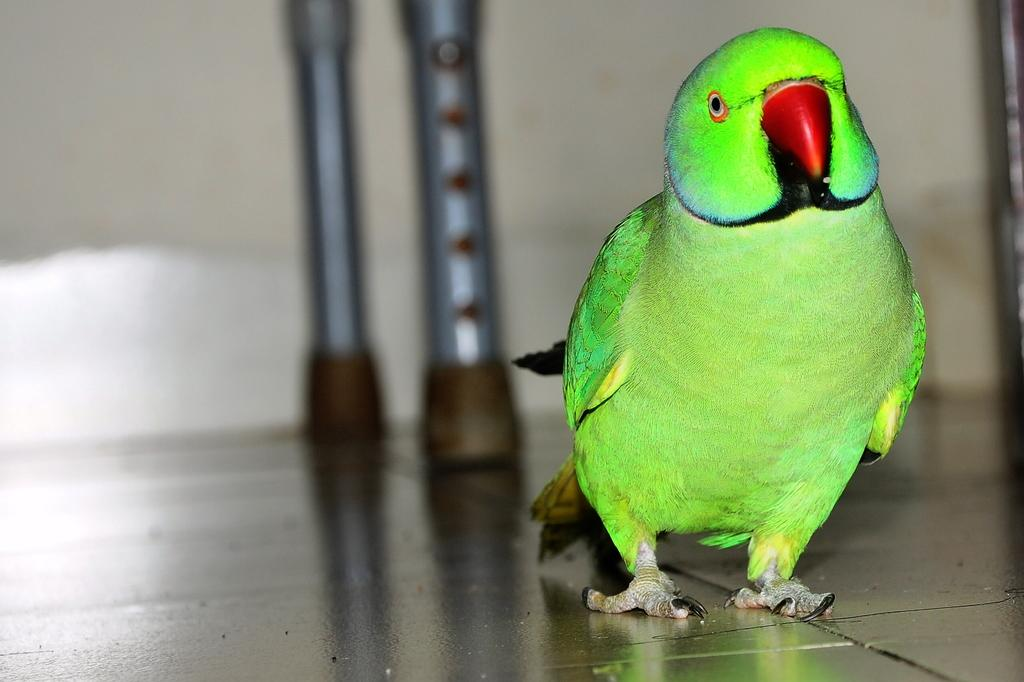What type of animal is in the image? There is a parrot in the image. Where is the parrot located? The parrot is on the floor. What can be seen in the background of the image? There is a wall in the background of the image. How would you describe the background in the image? The background appears blurred. How many family members are visible in the image? There are no family members visible in the image; it features a parrot on the floor. What type of furniture can be seen in the image? There is no furniture present in the image; it only features a parrot on the floor and a blurred background. 